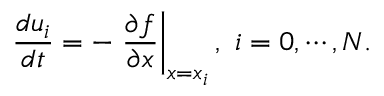<formula> <loc_0><loc_0><loc_500><loc_500>\frac { d u _ { i } } { d t } = - \frac { \partial f } { \partial x } \right | _ { x = x _ { i } } , i = 0 , \cdots , N .</formula> 